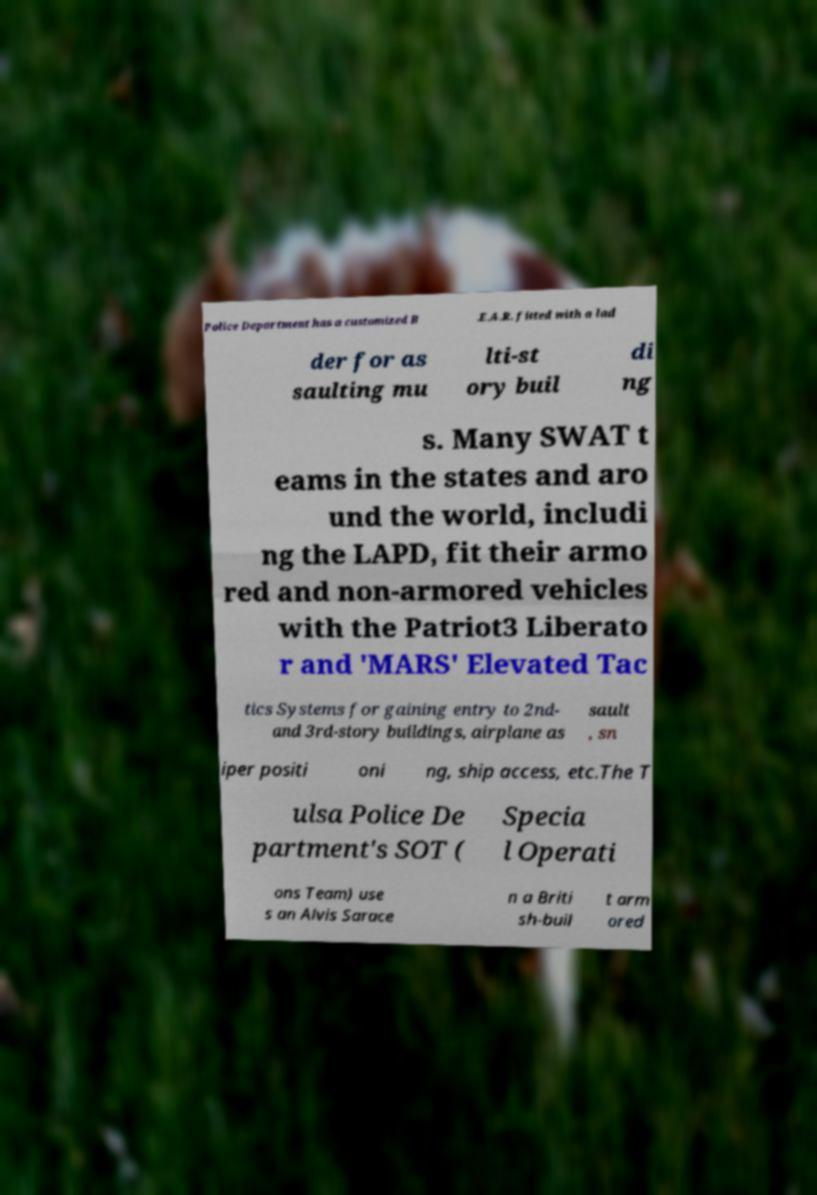I need the written content from this picture converted into text. Can you do that? Police Department has a customized B .E.A.R. fitted with a lad der for as saulting mu lti-st ory buil di ng s. Many SWAT t eams in the states and aro und the world, includi ng the LAPD, fit their armo red and non-armored vehicles with the Patriot3 Liberato r and 'MARS' Elevated Tac tics Systems for gaining entry to 2nd- and 3rd-story buildings, airplane as sault , sn iper positi oni ng, ship access, etc.The T ulsa Police De partment's SOT ( Specia l Operati ons Team) use s an Alvis Sarace n a Briti sh-buil t arm ored 